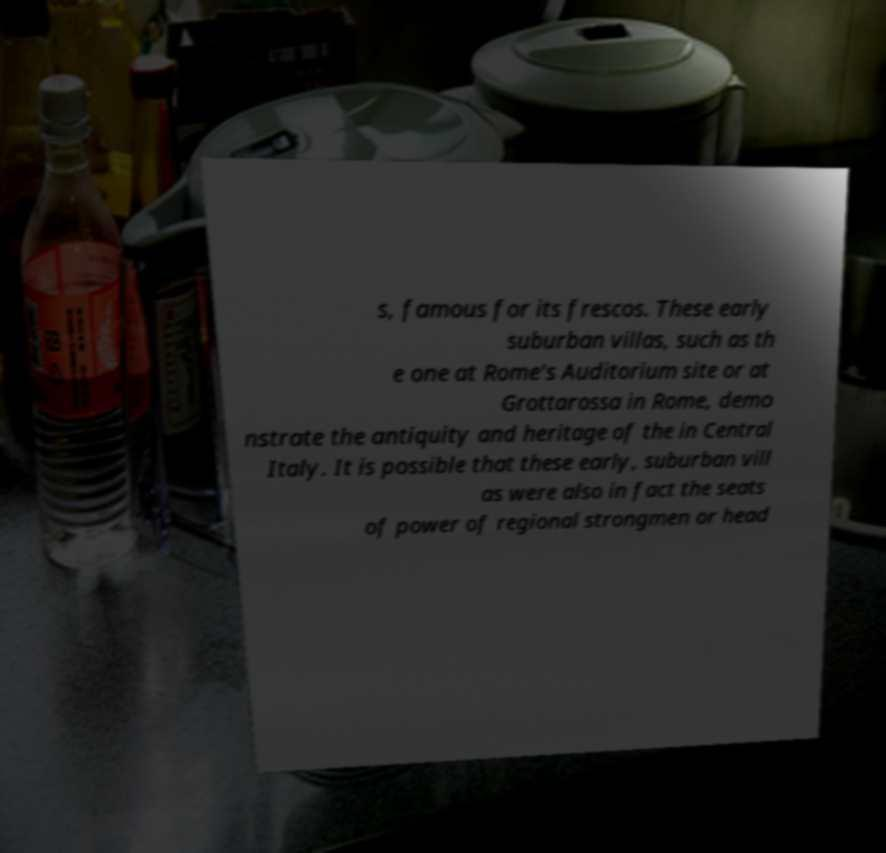Please identify and transcribe the text found in this image. s, famous for its frescos. These early suburban villas, such as th e one at Rome's Auditorium site or at Grottarossa in Rome, demo nstrate the antiquity and heritage of the in Central Italy. It is possible that these early, suburban vill as were also in fact the seats of power of regional strongmen or head 